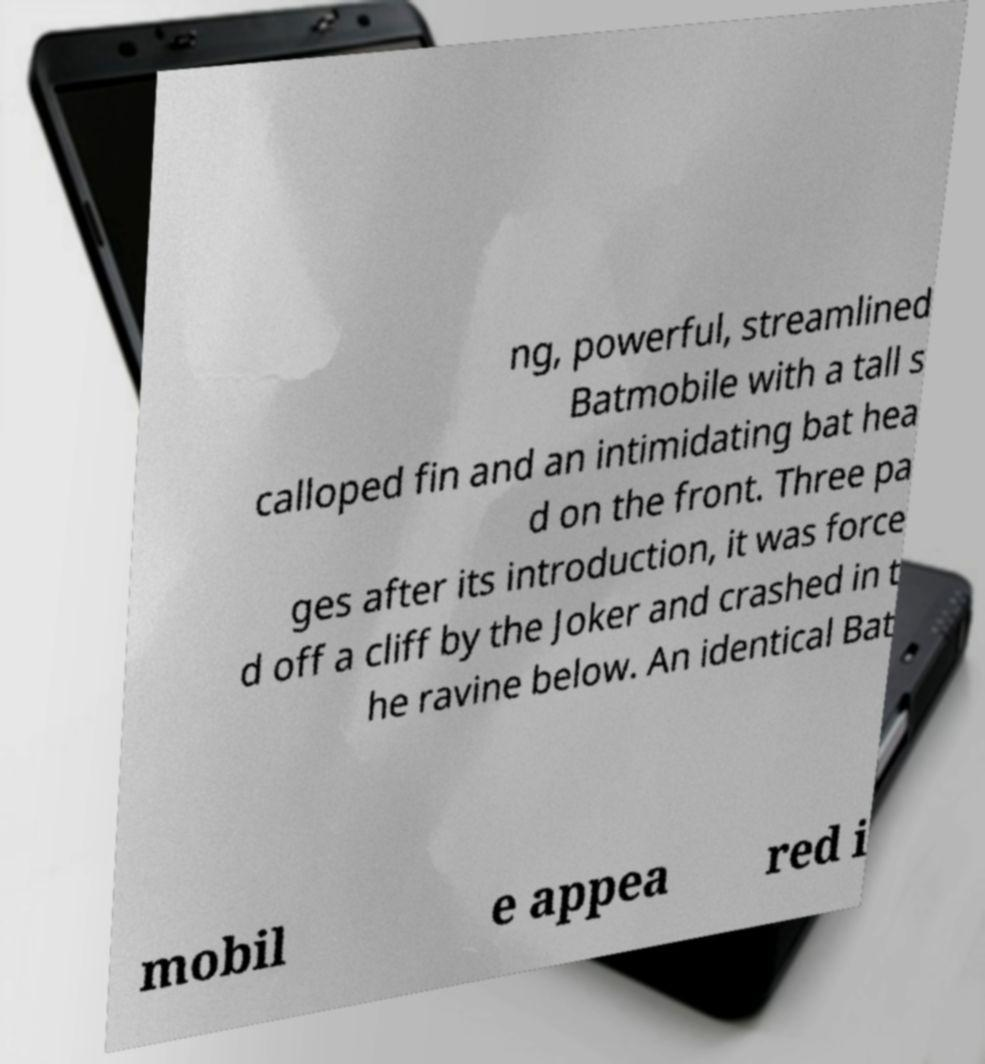Can you accurately transcribe the text from the provided image for me? ng, powerful, streamlined Batmobile with a tall s calloped fin and an intimidating bat hea d on the front. Three pa ges after its introduction, it was force d off a cliff by the Joker and crashed in t he ravine below. An identical Bat mobil e appea red i 